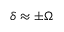<formula> <loc_0><loc_0><loc_500><loc_500>\delta \approx \pm \Omega</formula> 